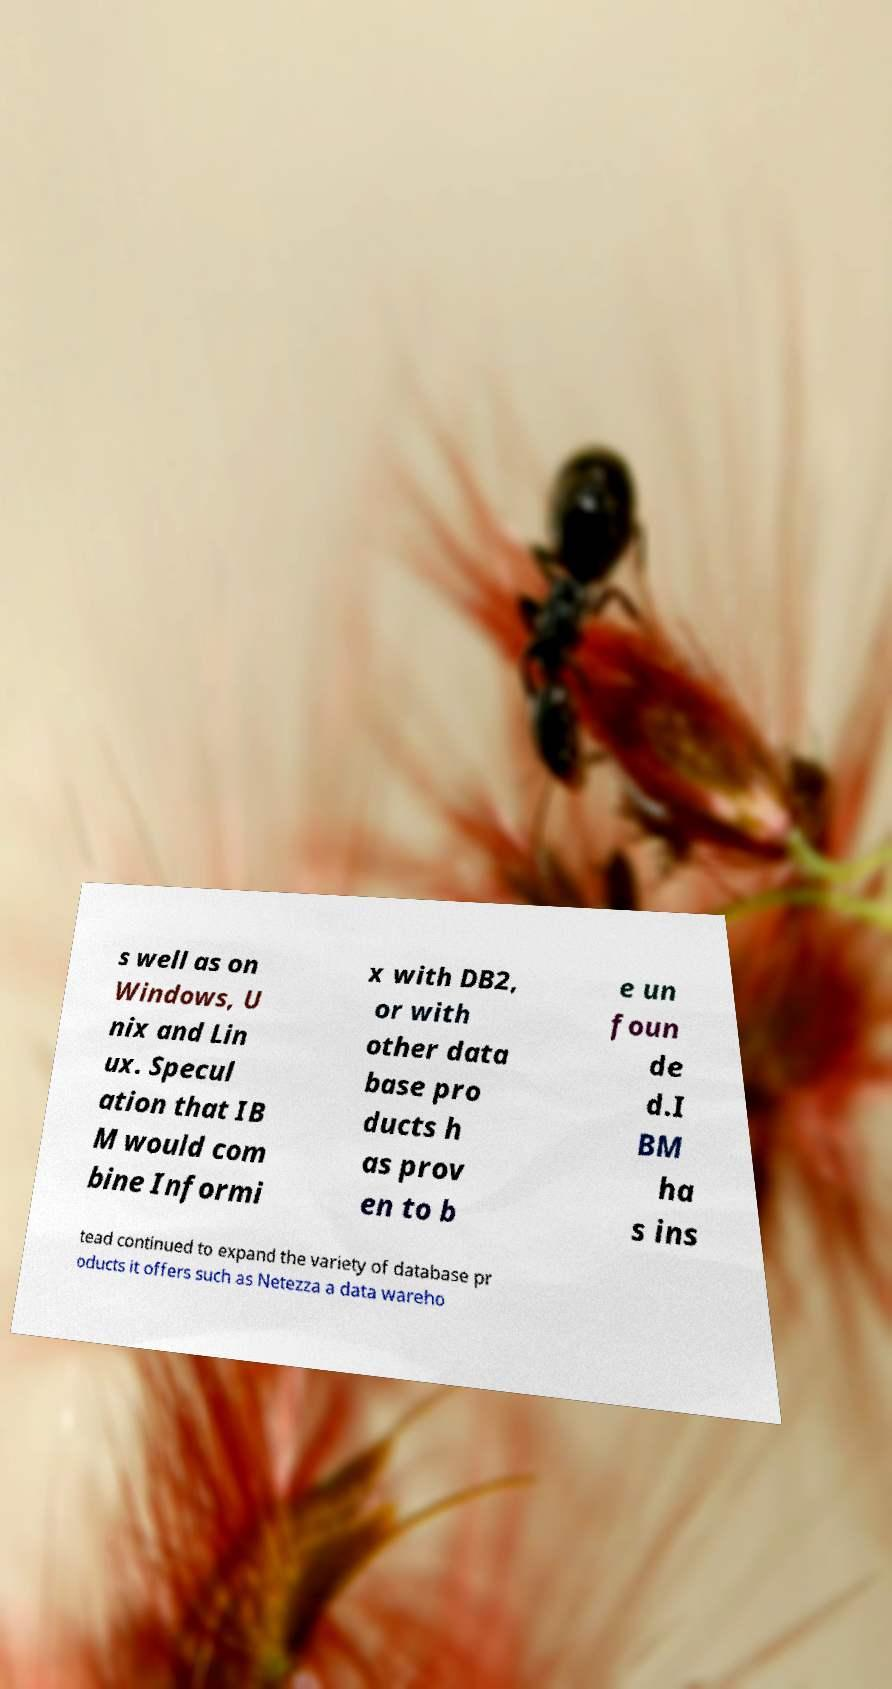What messages or text are displayed in this image? I need them in a readable, typed format. s well as on Windows, U nix and Lin ux. Specul ation that IB M would com bine Informi x with DB2, or with other data base pro ducts h as prov en to b e un foun de d.I BM ha s ins tead continued to expand the variety of database pr oducts it offers such as Netezza a data wareho 